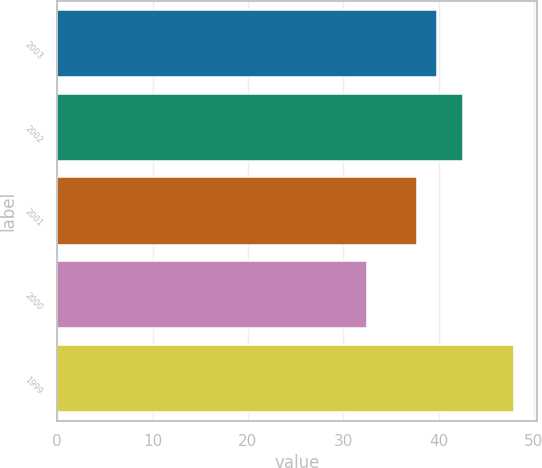<chart> <loc_0><loc_0><loc_500><loc_500><bar_chart><fcel>2003<fcel>2002<fcel>2001<fcel>2000<fcel>1999<nl><fcel>39.88<fcel>42.51<fcel>37.75<fcel>32.5<fcel>47.94<nl></chart> 